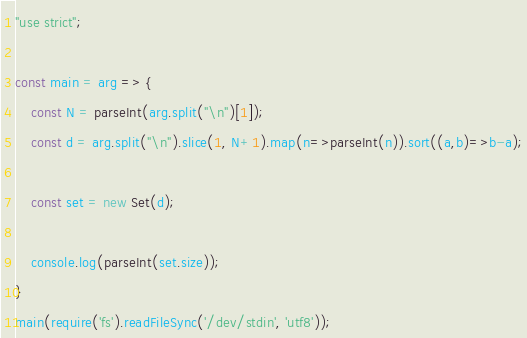Convert code to text. <code><loc_0><loc_0><loc_500><loc_500><_JavaScript_>"use strict";
    
const main = arg => {
    const N = parseInt(arg.split("\n")[1]);
    const d = arg.split("\n").slice(1, N+1).map(n=>parseInt(n)).sort((a,b)=>b-a);
    
    const set = new Set(d);
    
    console.log(parseInt(set.size));
}
main(require('fs').readFileSync('/dev/stdin', 'utf8'));
</code> 